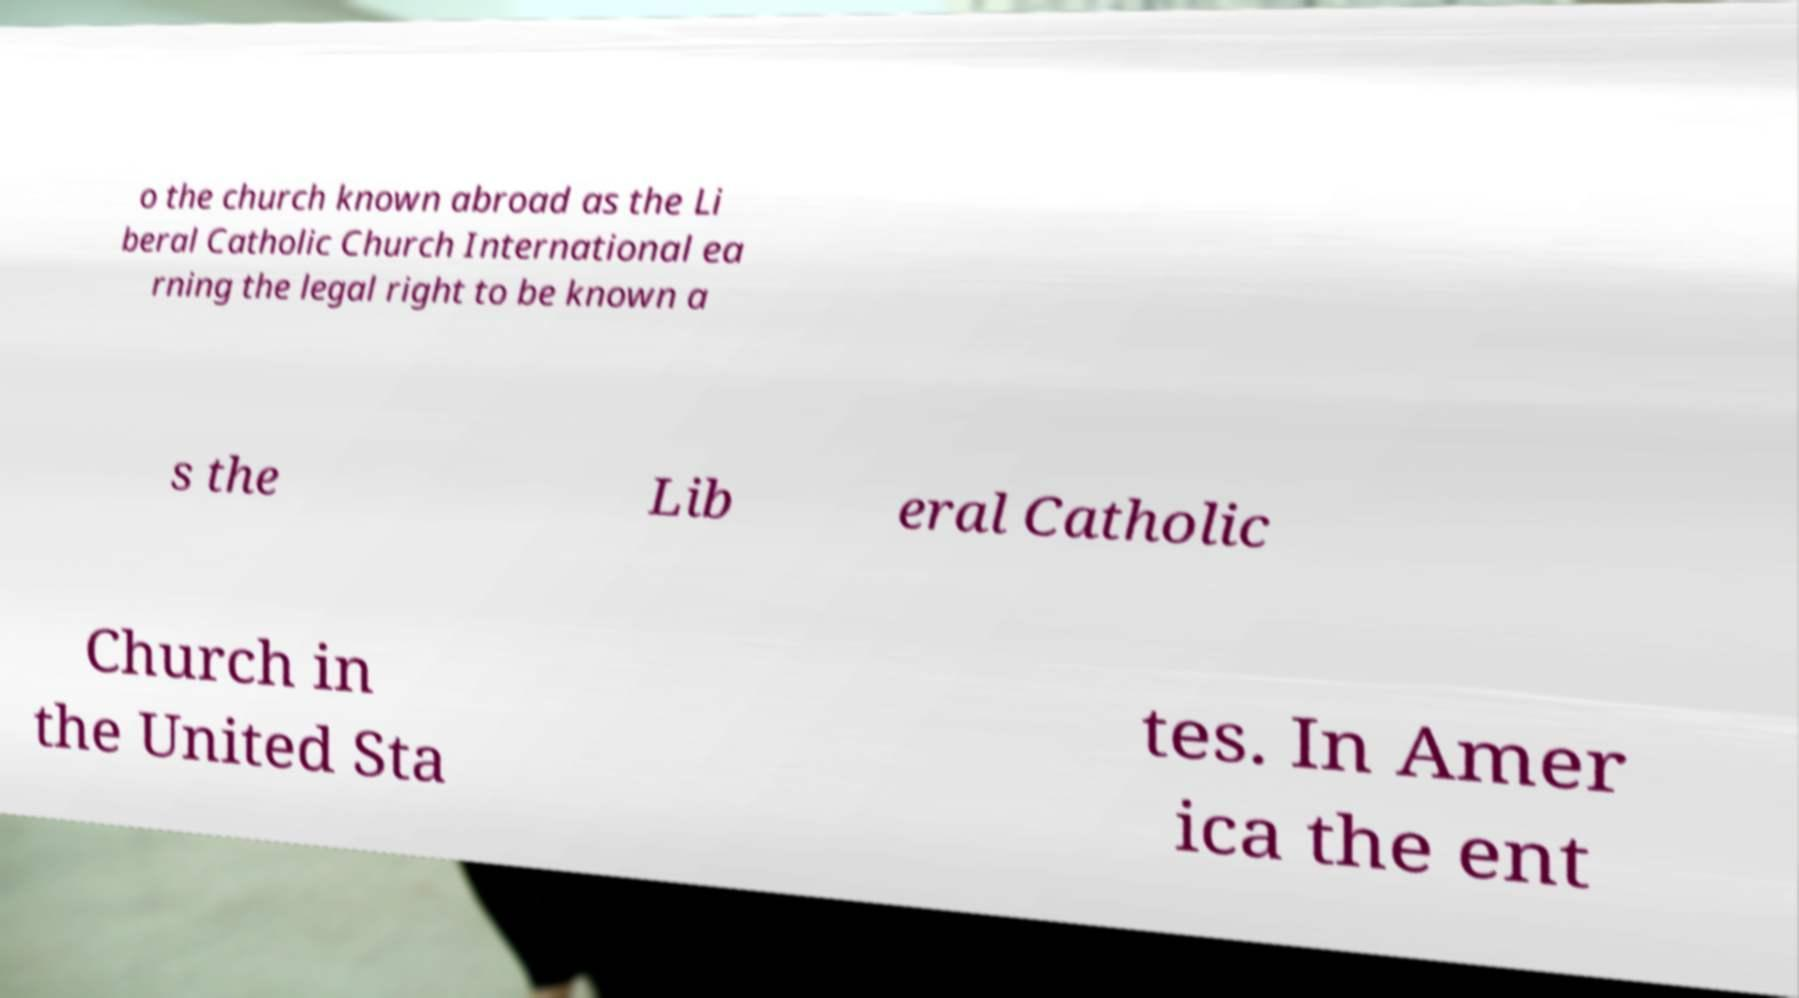I need the written content from this picture converted into text. Can you do that? o the church known abroad as the Li beral Catholic Church International ea rning the legal right to be known a s the Lib eral Catholic Church in the United Sta tes. In Amer ica the ent 